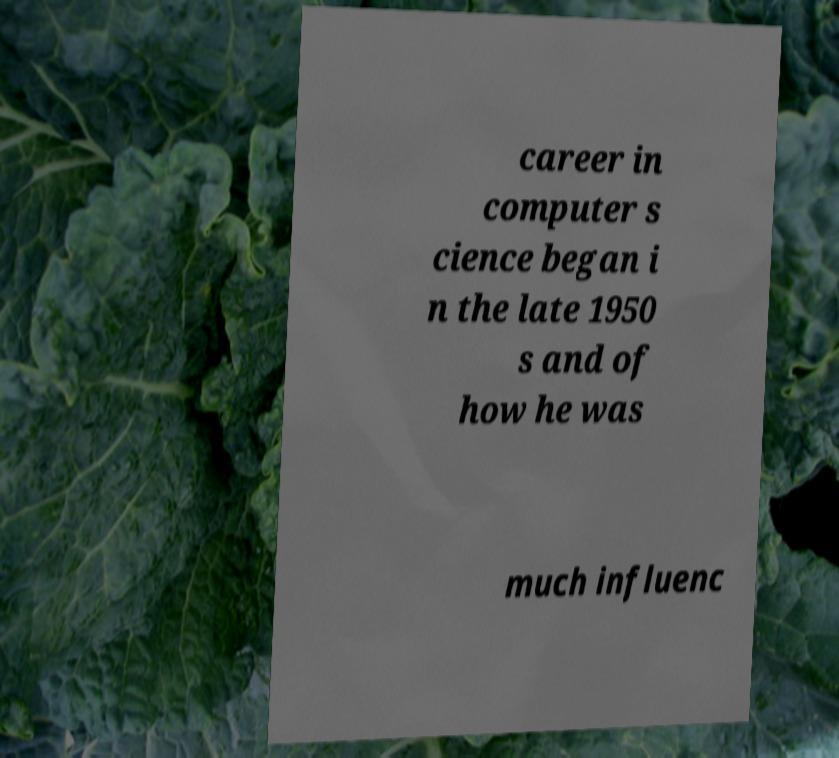Can you read and provide the text displayed in the image?This photo seems to have some interesting text. Can you extract and type it out for me? career in computer s cience began i n the late 1950 s and of how he was much influenc 